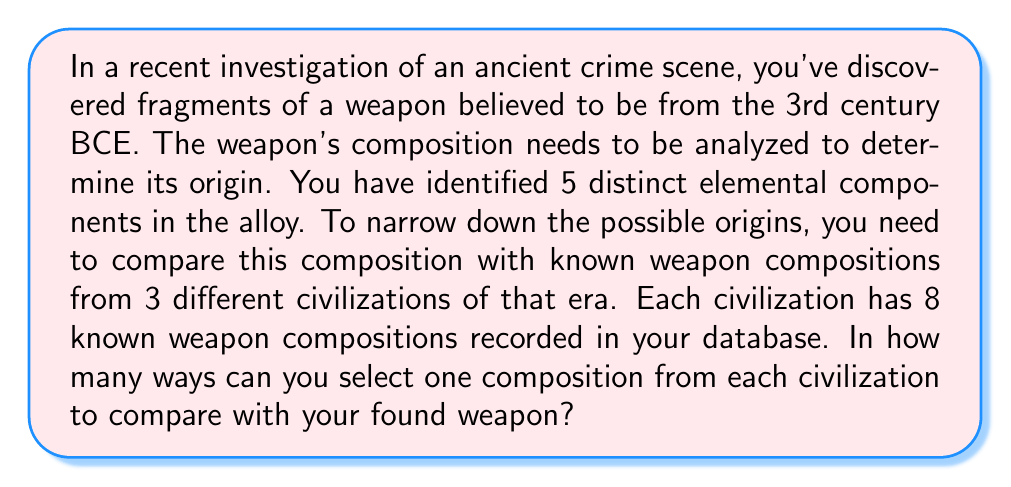Teach me how to tackle this problem. To solve this problem, we need to use the multiplication principle of combinatorial analysis. This principle states that if we have a sequence of $n$ independent events, and each event $i$ can occur in $m_i$ ways, then the total number of ways the entire sequence of events can occur is the product of all $m_i$.

In this case, we have three independent events:
1. Selecting a composition from the first civilization
2. Selecting a composition from the second civilization
3. Selecting a composition from the third civilization

For each civilization, we have 8 known weapon compositions to choose from.

Therefore:
- We can select a composition from the first civilization in 8 ways
- We can select a composition from the second civilization in 8 ways
- We can select a composition from the third civilization in 8 ways

Using the multiplication principle, the total number of ways to select one composition from each civilization is:

$$ 8 \times 8 \times 8 = 8^3 = 512 $$

This means there are 512 different possible combinations of weapon compositions (one from each civilization) that you can compare with your found weapon.
Answer: 512 